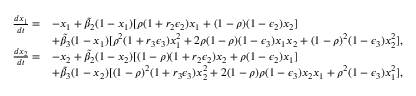<formula> <loc_0><loc_0><loc_500><loc_500>\begin{array} { r l } { \frac { d x _ { 1 } } { d t } = } & { - x _ { 1 } + \widetilde { \beta } _ { 2 } ( 1 - x _ { 1 } ) [ \rho ( 1 + r _ { 2 } \epsilon _ { 2 } ) x _ { 1 } + ( 1 - \rho ) ( 1 - \epsilon _ { 2 } ) x _ { 2 } ] } \\ & { + \widetilde { \beta } _ { 3 } ( 1 - x _ { 1 } ) [ \rho ^ { 2 } ( 1 + r _ { 3 } \epsilon _ { 3 } ) x _ { 1 } ^ { 2 } + 2 \rho ( 1 - \rho ) ( 1 - \epsilon _ { 3 } ) x _ { 1 } x _ { 2 } + ( 1 - \rho ) ^ { 2 } ( 1 - \epsilon _ { 3 } ) x _ { 2 } ^ { 2 } ] , } \\ { \frac { d x _ { 2 } } { d t } = } & { - x _ { 2 } + \widetilde { \beta } _ { 2 } ( 1 - x _ { 2 } ) [ ( 1 - \rho ) ( 1 + r _ { 2 } \epsilon _ { 2 } ) x _ { 2 } + \rho ( 1 - \epsilon _ { 2 } ) x _ { 1 } ] } \\ & { + \widetilde { \beta } _ { 3 } ( 1 - x _ { 2 } ) [ ( 1 - \rho ) ^ { 2 } ( 1 + r _ { 3 } \epsilon _ { 3 } ) x _ { 2 } ^ { 2 } + 2 ( 1 - \rho ) \rho ( 1 - \epsilon _ { 3 } ) x _ { 2 } x _ { 1 } + \rho ^ { 2 } ( 1 - \epsilon _ { 3 } ) x _ { 1 } ^ { 2 } ] , } \end{array}</formula> 